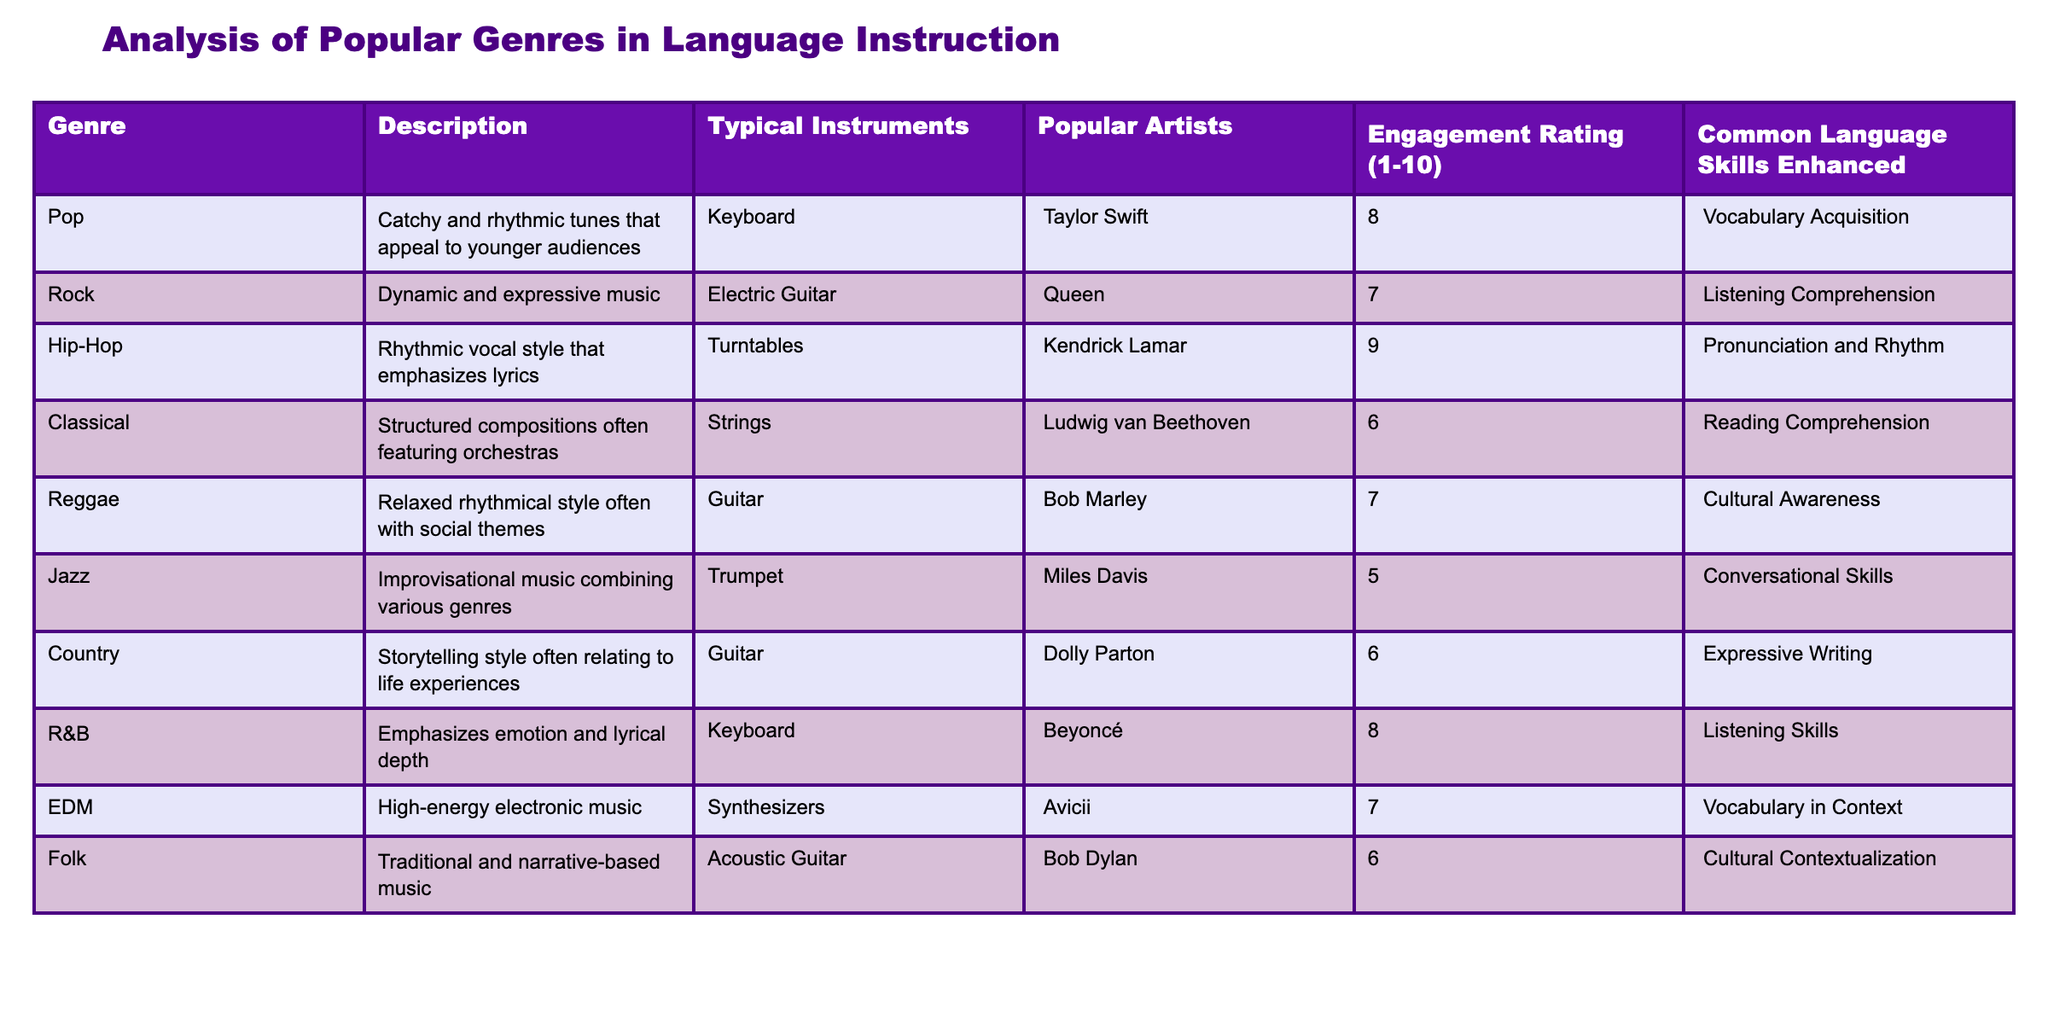What genre has the highest engagement rating? The engagement ratings for each genre are listed in the "Engagement Rating (1-10)" column. By scanning the values, Hip-Hop has the highest rating of 9.
Answer: Hip-Hop What common language skill is most enhanced by Pop music? The "Common Language Skills Enhanced" column indicates that Pop music enhances Vocabulary Acquisition. This can be found in the row corresponding to the Pop genre.
Answer: Vocabulary Acquisition Which genre does not enhance Conversational Skills? By examining the "Common Language Skills Enhanced" column, Jazz is the only genre listed that does not enhance Conversational Skills, which only appears under the Jazz genre.
Answer: Yes What is the average engagement rating of genres that use Guitar as a typical instrument? The genres that feature Guitar are Reggae, Country, and Folk, with engagement ratings of 7, 6, and 6, respectively. The average calculated is (7 + 6 + 6) / 3 = 6.33.
Answer: 6.33 Is there a genre that enhances both Cultural Awareness and Cultural Contextualization? Looking at the "Common Language Skills Enhanced" column, Reggae enhances Cultural Awareness and Folk enhances Cultural Contextualization. There is no single genre that enhances both.
Answer: No Which two genres have the same engagement rating? By scanning the "Engagement Rating (1-10) column, we notice that Rock and Reggae both have an engagement rating of 7.
Answer: Rock and Reggae What genre has the lowest engagement rating, and what common language skill does it enhance? The lowest rating in the "Engagement Rating (1-10)" column is Jazz with a score of 5. The skill enhanced is Conversational Skills, as indicated in its row.
Answer: Jazz, Conversational Skills How many genres enhance Listening Skills, and what are they? The "Common Language Skills Enhanced" column shows that Hip-Hop and R&B both enhance Listening Skills. Thus, there are two genres.
Answer: 2 (Hip-Hop, R&B) Which genre primarily enhances Reading Comprehension? The genre with a focus on reading comprehension is Classical, as indicated in its corresponding row under "Common Language Skills Enhanced."
Answer: Classical 